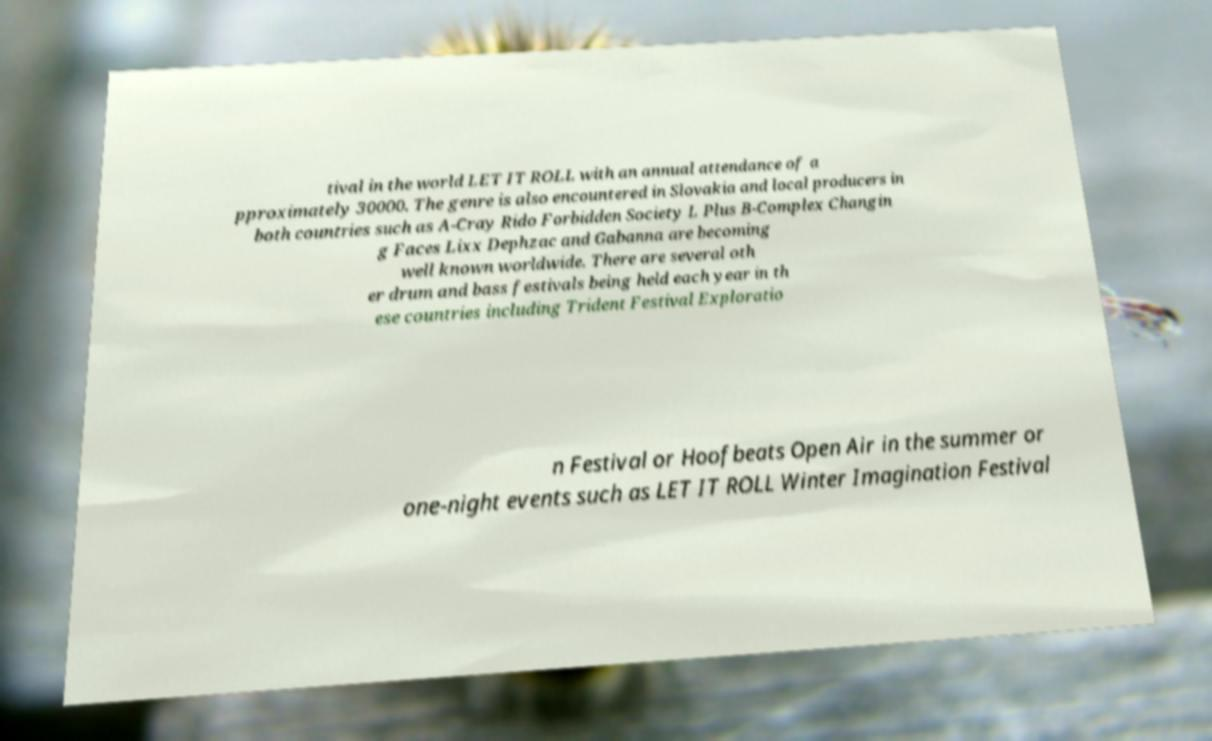Could you assist in decoding the text presented in this image and type it out clearly? tival in the world LET IT ROLL with an annual attendance of a pproximately 30000. The genre is also encountered in Slovakia and local producers in both countries such as A-Cray Rido Forbidden Society L Plus B-Complex Changin g Faces Lixx Dephzac and Gabanna are becoming well known worldwide. There are several oth er drum and bass festivals being held each year in th ese countries including Trident Festival Exploratio n Festival or Hoofbeats Open Air in the summer or one-night events such as LET IT ROLL Winter Imagination Festival 